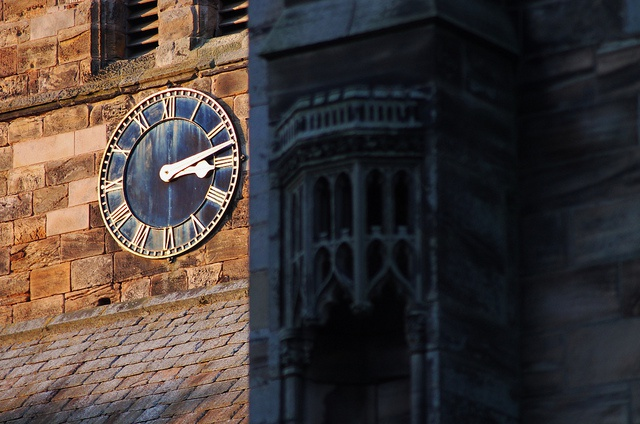Describe the objects in this image and their specific colors. I can see a clock in brown, gray, ivory, black, and darkgray tones in this image. 